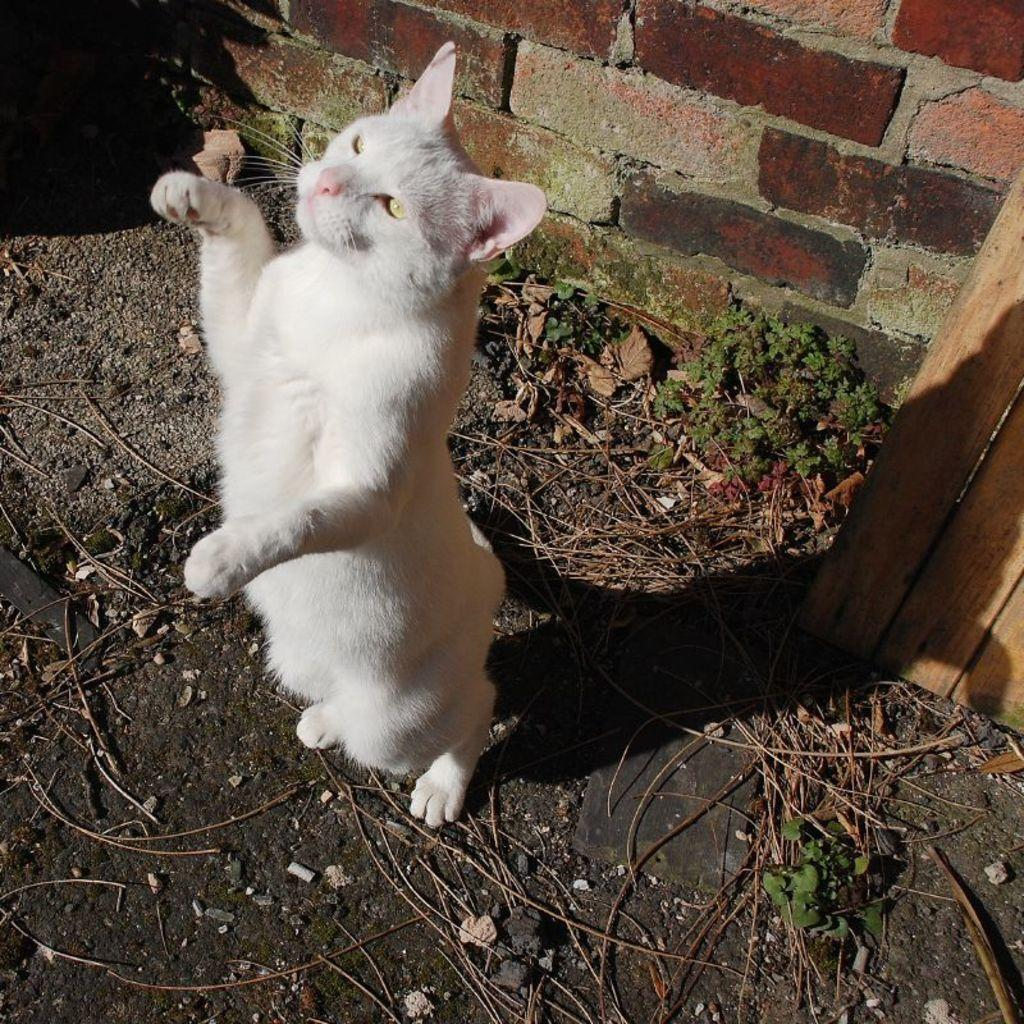What type of animal is in the image? There is a cat in the image. What color is the cat? The cat is white. What can be seen in the background of the image? There are plants in the background of the image. What color are the plants? The plants are green. How would you describe the wall in the background? The wall in the background is brown and gray. What type of agreement did the cat and the dad reach in the image? There is no dad present in the image, and no agreement is mentioned or depicted. 